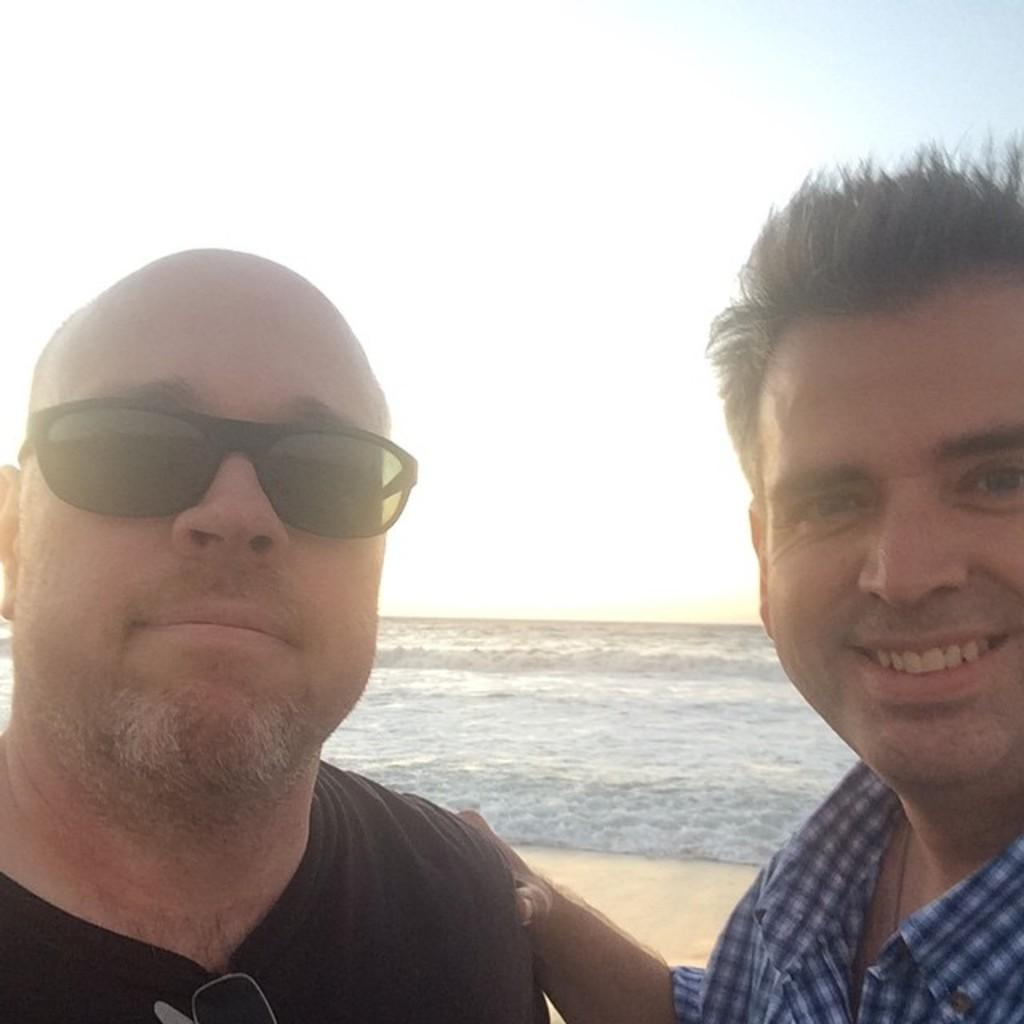What is the main subject of the image? There are two men in the image. Can you describe the clothing of the first man? The first man is wearing a blue T-shirt and black spectacles. What about the second man's clothing? The second man is wearing a blue and white color shirt. What can be seen in the background of the image? There is a beach and sky visible in the background of the image. How many geese are present in the image? There are no geese present in the image. What type of smile does the boy in the image have? There is no boy present in the image; it features two men. 